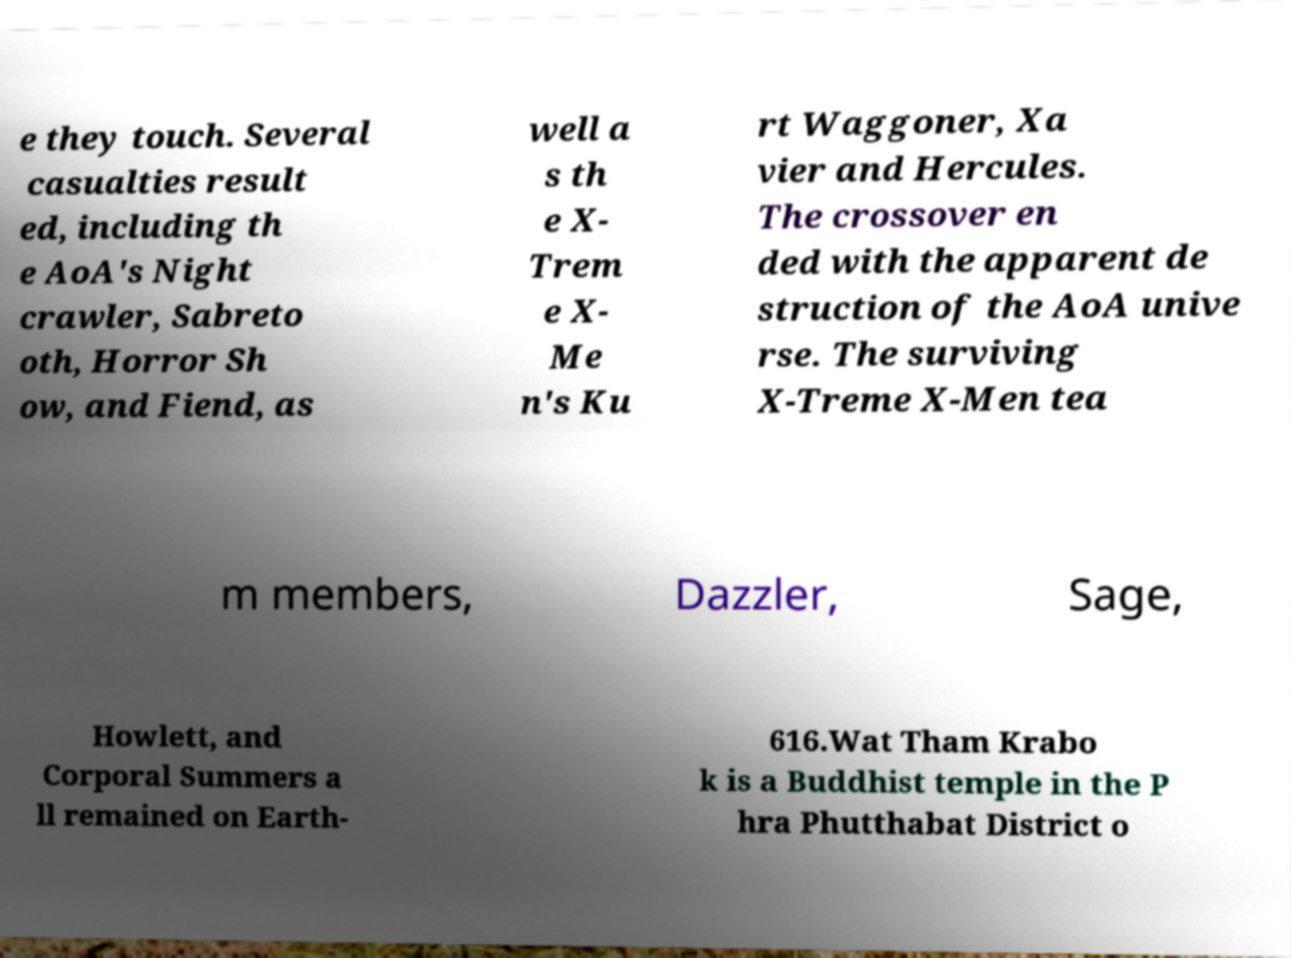What messages or text are displayed in this image? I need them in a readable, typed format. e they touch. Several casualties result ed, including th e AoA's Night crawler, Sabreto oth, Horror Sh ow, and Fiend, as well a s th e X- Trem e X- Me n's Ku rt Waggoner, Xa vier and Hercules. The crossover en ded with the apparent de struction of the AoA unive rse. The surviving X-Treme X-Men tea m members, Dazzler, Sage, Howlett, and Corporal Summers a ll remained on Earth- 616.Wat Tham Krabo k is a Buddhist temple in the P hra Phutthabat District o 